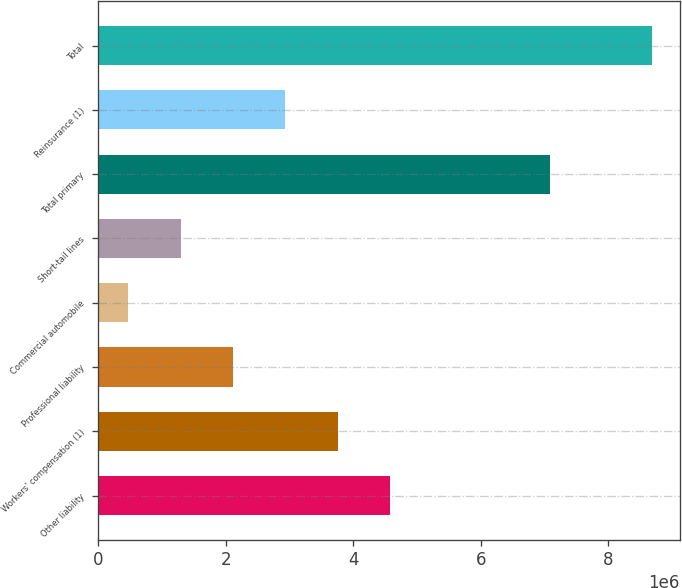Convert chart to OTSL. <chart><loc_0><loc_0><loc_500><loc_500><bar_chart><fcel>Other liability<fcel>Workers' compensation (1)<fcel>Professional liability<fcel>Commercial automobile<fcel>Short-tail lines<fcel>Total primary<fcel>Reinsurance (1)<fcel>Total<nl><fcel>4.57845e+06<fcel>3.75738e+06<fcel>2.11524e+06<fcel>473105<fcel>1.29417e+06<fcel>7.08611e+06<fcel>2.93631e+06<fcel>8.6838e+06<nl></chart> 